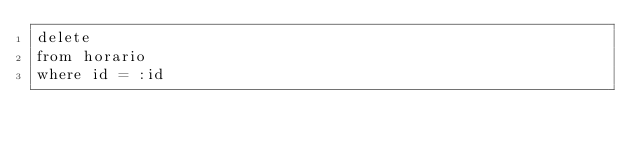<code> <loc_0><loc_0><loc_500><loc_500><_SQL_>delete 
from horario
where id = :id</code> 